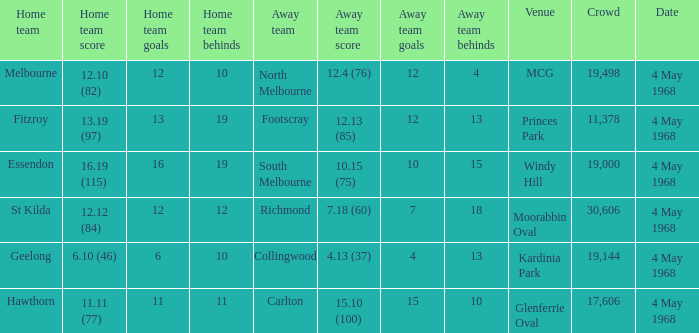How big was the crowd of the team that scored 4.13 (37)? 19144.0. 